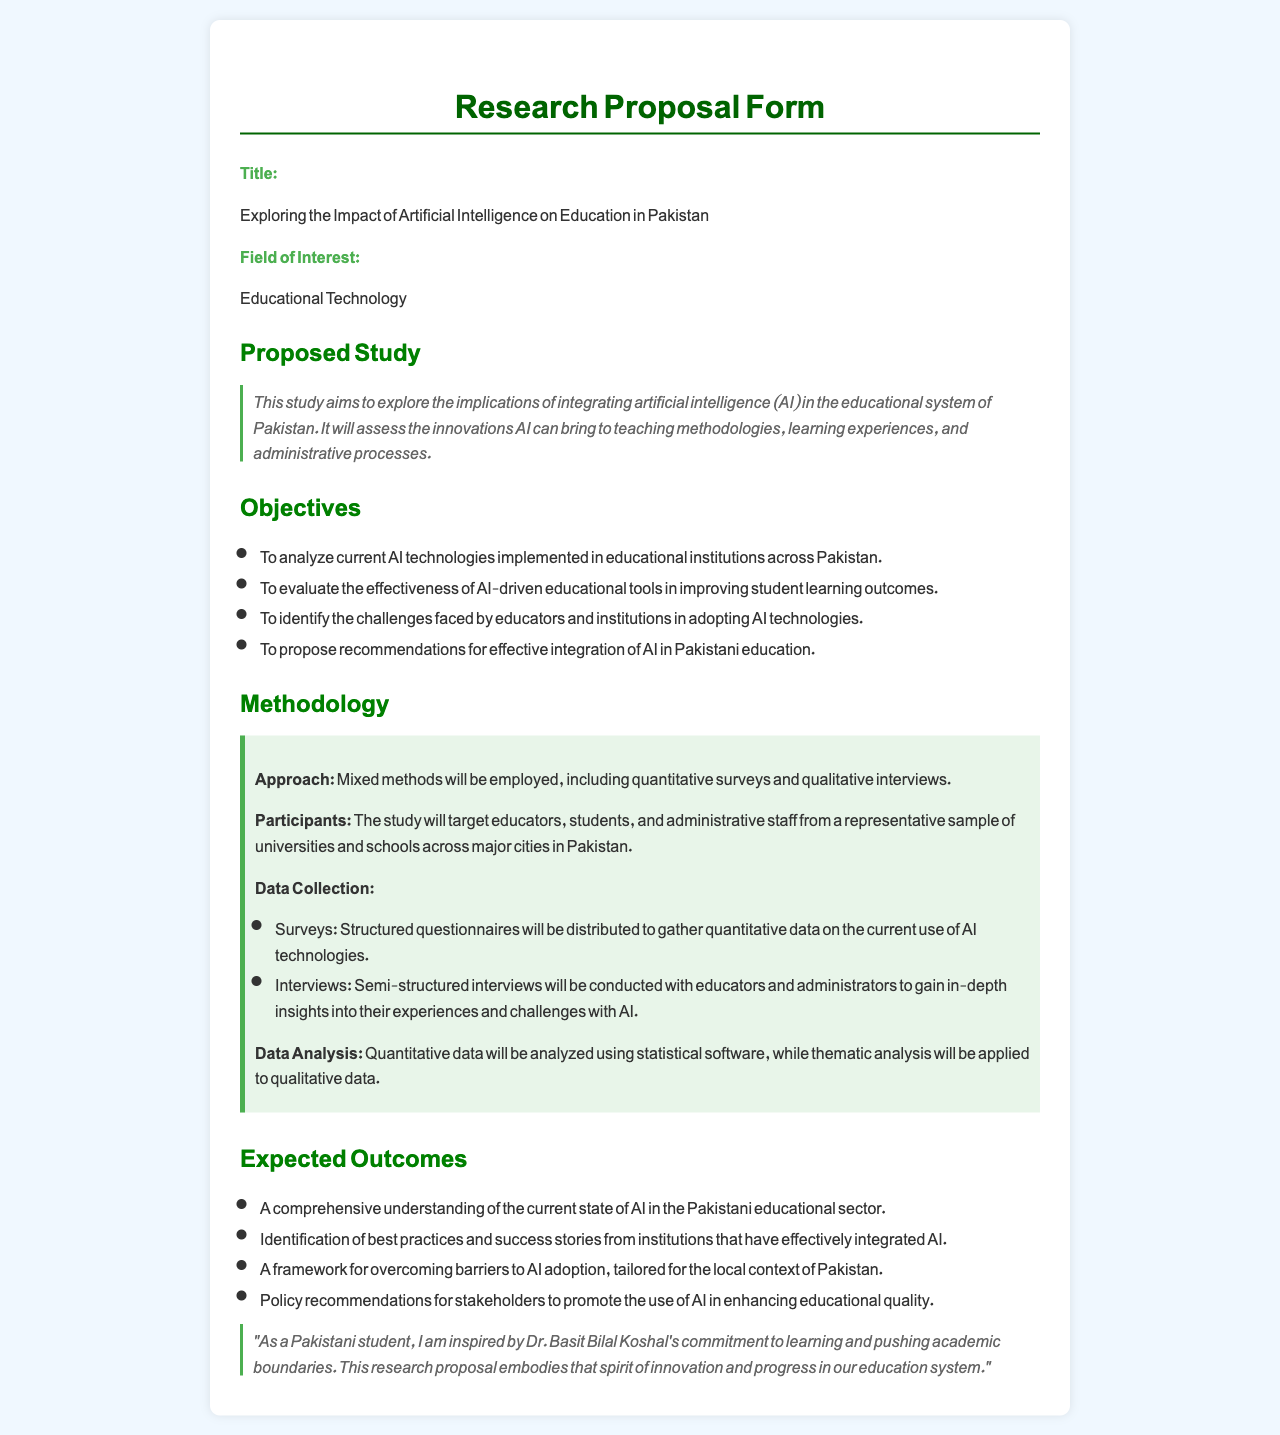What is the title of the research proposal? The title of the research proposal is explicitly stated in the document's title section.
Answer: Exploring the Impact of Artificial Intelligence on Education in Pakistan What is the field of interest? The field of interest is mentioned directly in the document under the relevant section.
Answer: Educational Technology What are the first two objectives of the study? The objectives are listed in bullet points, and the first two can be extracted from there.
Answer: To analyze current AI technologies implemented in educational institutions across Pakistan. To evaluate the effectiveness of AI-driven educational tools in improving student learning outcomes What type of methodology is proposed in the study? The methodology is defined in a section of the document, where the approach is described.
Answer: Mixed methods Who are the targeted participants for the study? The participants are mentioned, specifically which groups will be involved in the research.
Answer: Educators, students, and administrative staff What is one expected outcome of the study? The expected outcomes are listed in a section of the document, and one can be cited as an answer.
Answer: A comprehensive understanding of the current state of AI in the Pakistani educational sector Which analysis method will be used for the qualitative data? The method for analyzing qualitative data is explicitly described in the methodology section.
Answer: Thematic analysis What is the primary focus of the proposed study? The primary focus is stated in an introductory quote within the proposed study section.
Answer: Implications of integrating artificial intelligence (AI) in the educational system of Pakistan 